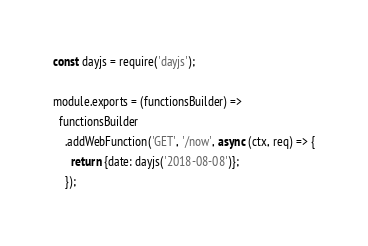<code> <loc_0><loc_0><loc_500><loc_500><_JavaScript_>const dayjs = require('dayjs');

module.exports = (functionsBuilder) =>
  functionsBuilder
    .addWebFunction('GET', '/now', async (ctx, req) => {
      return {date: dayjs('2018-08-08')};
    });</code> 